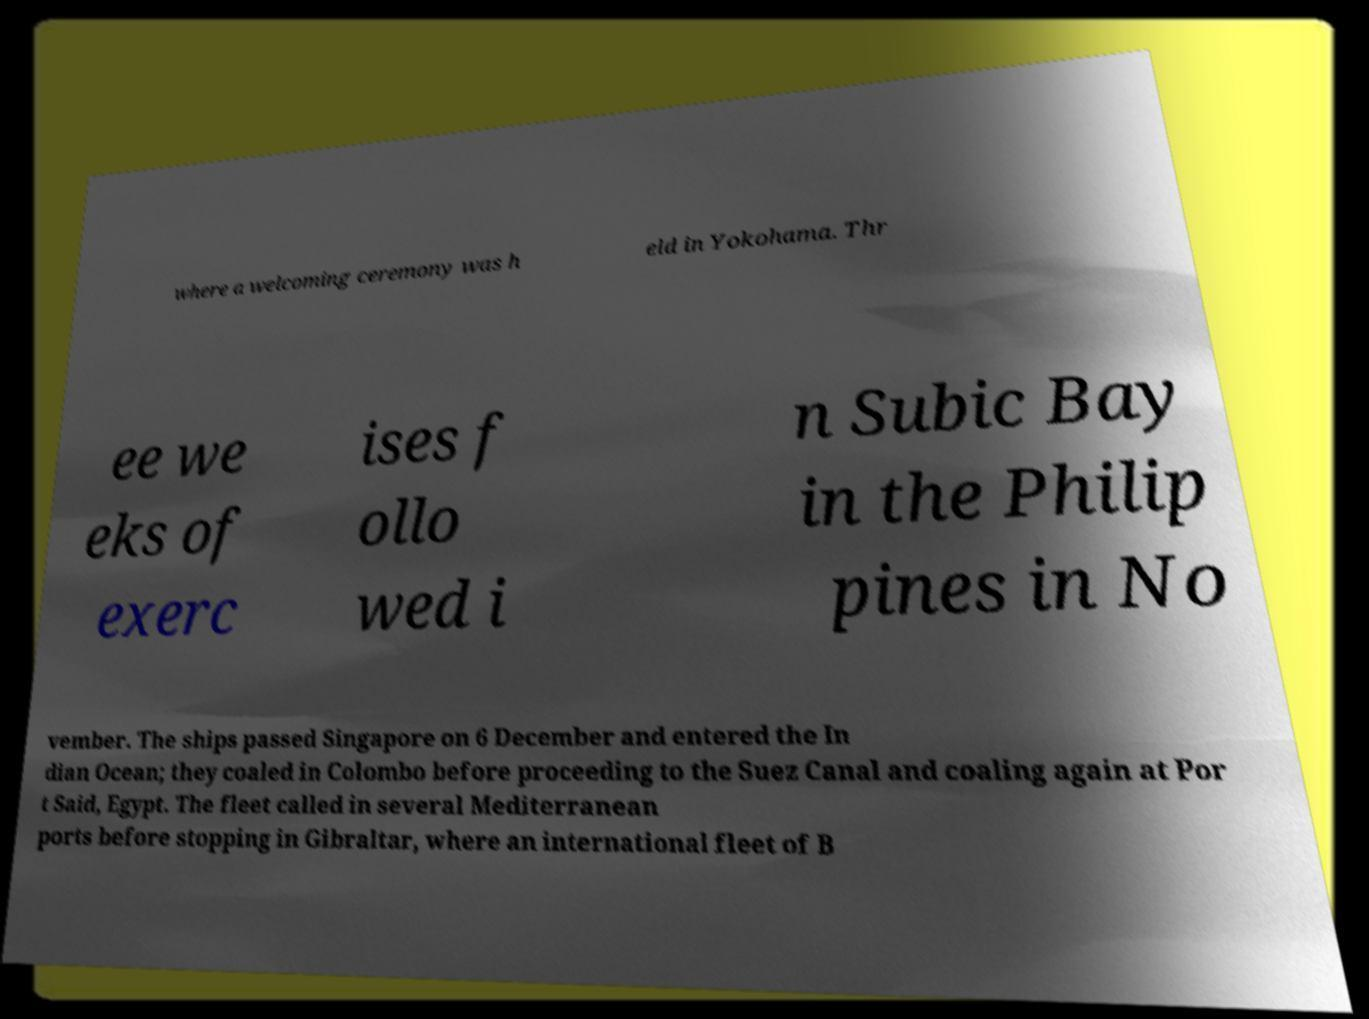There's text embedded in this image that I need extracted. Can you transcribe it verbatim? where a welcoming ceremony was h eld in Yokohama. Thr ee we eks of exerc ises f ollo wed i n Subic Bay in the Philip pines in No vember. The ships passed Singapore on 6 December and entered the In dian Ocean; they coaled in Colombo before proceeding to the Suez Canal and coaling again at Por t Said, Egypt. The fleet called in several Mediterranean ports before stopping in Gibraltar, where an international fleet of B 